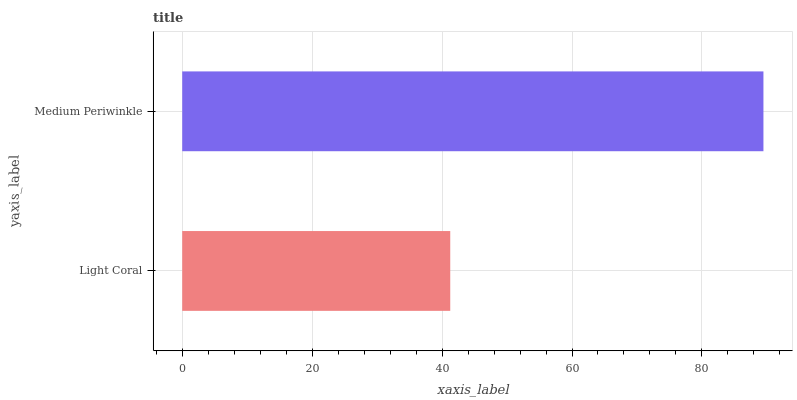Is Light Coral the minimum?
Answer yes or no. Yes. Is Medium Periwinkle the maximum?
Answer yes or no. Yes. Is Medium Periwinkle the minimum?
Answer yes or no. No. Is Medium Periwinkle greater than Light Coral?
Answer yes or no. Yes. Is Light Coral less than Medium Periwinkle?
Answer yes or no. Yes. Is Light Coral greater than Medium Periwinkle?
Answer yes or no. No. Is Medium Periwinkle less than Light Coral?
Answer yes or no. No. Is Medium Periwinkle the high median?
Answer yes or no. Yes. Is Light Coral the low median?
Answer yes or no. Yes. Is Light Coral the high median?
Answer yes or no. No. Is Medium Periwinkle the low median?
Answer yes or no. No. 